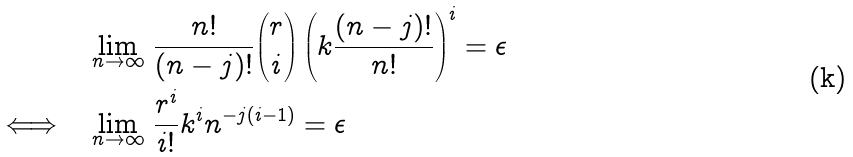<formula> <loc_0><loc_0><loc_500><loc_500>& \lim _ { n \to \infty } \, \frac { n ! } { ( n - j ) ! } \binom { r } { i } \left ( k \frac { ( n - j ) ! } { n ! } \right ) ^ { i } = \epsilon \\ \Longleftrightarrow \quad & \lim _ { n \to \infty } \, \frac { r ^ { i } } { i ! } k ^ { i } n ^ { - j ( i - 1 ) } = \epsilon</formula> 